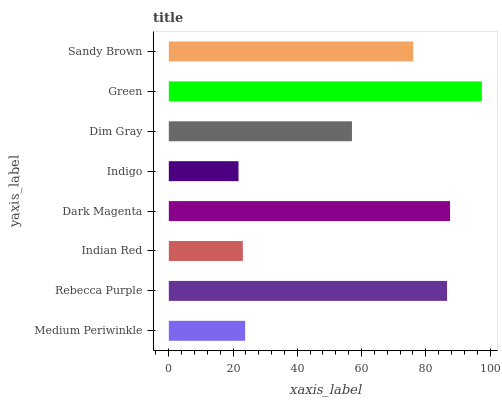Is Indigo the minimum?
Answer yes or no. Yes. Is Green the maximum?
Answer yes or no. Yes. Is Rebecca Purple the minimum?
Answer yes or no. No. Is Rebecca Purple the maximum?
Answer yes or no. No. Is Rebecca Purple greater than Medium Periwinkle?
Answer yes or no. Yes. Is Medium Periwinkle less than Rebecca Purple?
Answer yes or no. Yes. Is Medium Periwinkle greater than Rebecca Purple?
Answer yes or no. No. Is Rebecca Purple less than Medium Periwinkle?
Answer yes or no. No. Is Sandy Brown the high median?
Answer yes or no. Yes. Is Dim Gray the low median?
Answer yes or no. Yes. Is Dark Magenta the high median?
Answer yes or no. No. Is Dark Magenta the low median?
Answer yes or no. No. 